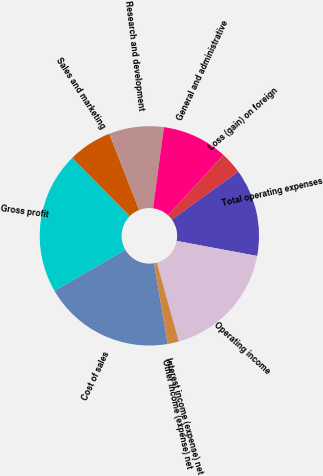Convert chart to OTSL. <chart><loc_0><loc_0><loc_500><loc_500><pie_chart><fcel>Cost of sales<fcel>Gross profit<fcel>Sales and marketing<fcel>Research and development<fcel>General and administrative<fcel>Loss (gain) on foreign<fcel>Total operating expenses<fcel>Operating income<fcel>Interest income (expense) net<fcel>Other income (expense) net<nl><fcel>19.33%<fcel>20.94%<fcel>6.46%<fcel>8.07%<fcel>9.68%<fcel>3.25%<fcel>12.89%<fcel>17.72%<fcel>0.03%<fcel>1.64%<nl></chart> 